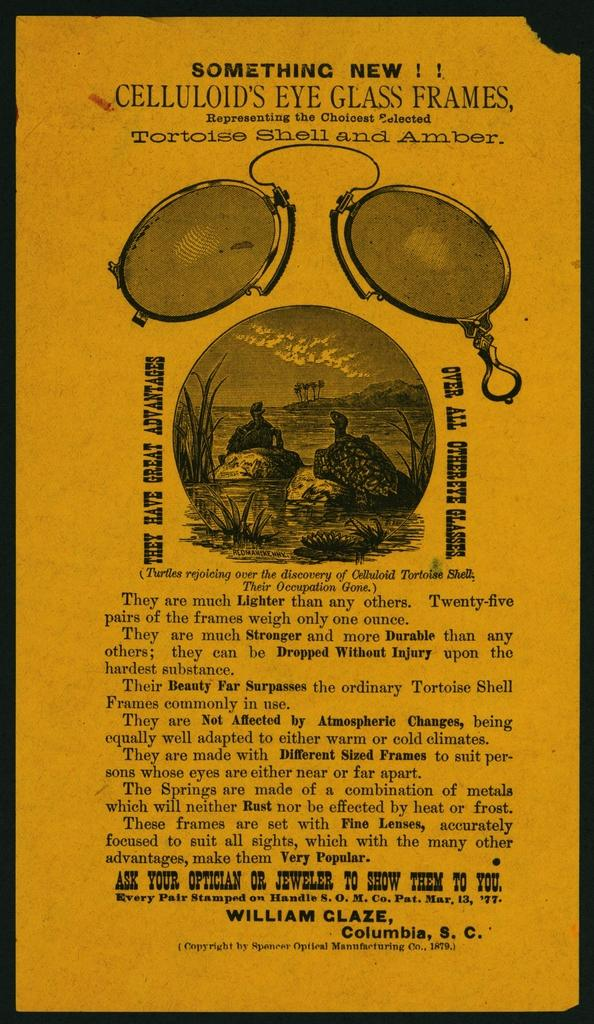<image>
Render a clear and concise summary of the photo. Poster that says "Something New" on top showing two tortoises having a conversation. 